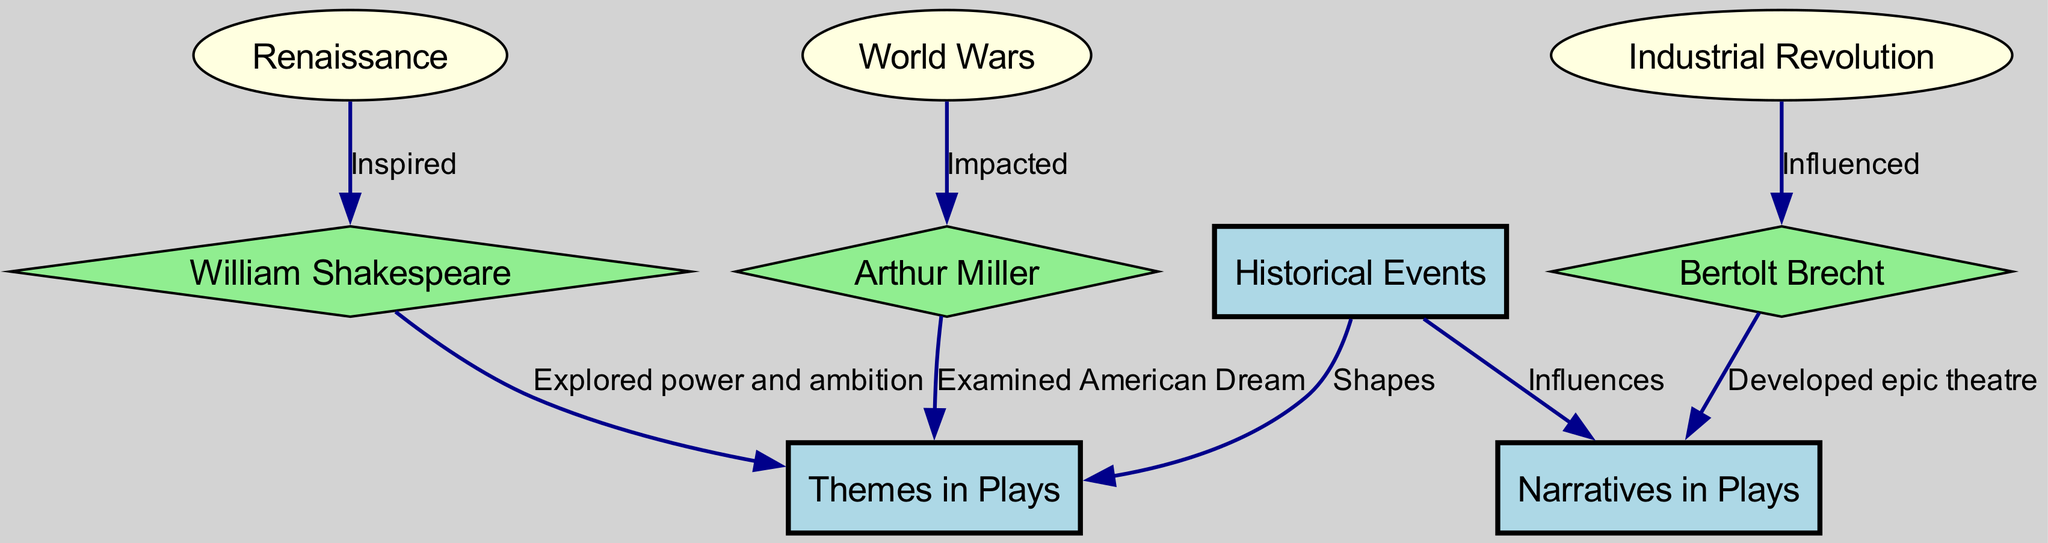What is the central theme influenced by historical events? The central theme common to many plays is the exploration of themes, which is directly connected to historical events as indicated by the edge labeled "Shapes."
Answer: Themes in Plays Which playwright is associated with the Renaissance? The diagram shows an edge from the Renaissance node to the William Shakespeare node labeled "Inspired," indicating that Shakespeare is the playwright connected to this historical event.
Answer: William Shakespeare How many edges are present in this concept map? By counting the connections presented in the edges section of the diagram, there are a total of 8 edges connecting various nodes.
Answer: 8 What theme does Arthur Miller examine in his work? The edge labeled "Examined American Dream" directly connects Arthur Miller to the theme, specifying what he focused on in his plays.
Answer: American Dream Which historical event influenced Bertolt Brecht? The influence on Brecht is indicated by the edge from the industrial revolution node to the brecht node, described with the label "Influenced."
Answer: Industrial Revolution What type of theatre did Brecht develop? The diagram shows an edge from Brecht to narratives labeled "Developed epic theatre," specifying the style of theatre he advocated.
Answer: Epic theatre Who explored themes of power and ambition? The connection from William Shakespeare to themes, marked with "Explored power and ambition," indicates that Shakespeare focused on these specific themes in his plays.
Answer: William Shakespeare Which playwright's work was impacted by the World Wars? The edge from the world wars node to the Miller node, with the label "Impacted," demonstrates that Arthur Miller was influenced by the events of the World Wars.
Answer: Arthur Miller What influences themes in plays? The diagram shows that historical events shapes themes in plays, as indicated by the edge linking historical events to themes labeled "Shapes."
Answer: Historical Events 